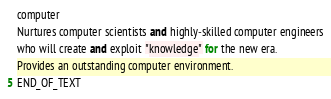Convert code to text. <code><loc_0><loc_0><loc_500><loc_500><_Python_>computer
Nurtures computer scientists and highly-skilled computer engineers
who will create and exploit "knowledge" for the new era.
Provides an outstanding computer environment.
END_OF_TEXT
</code> 